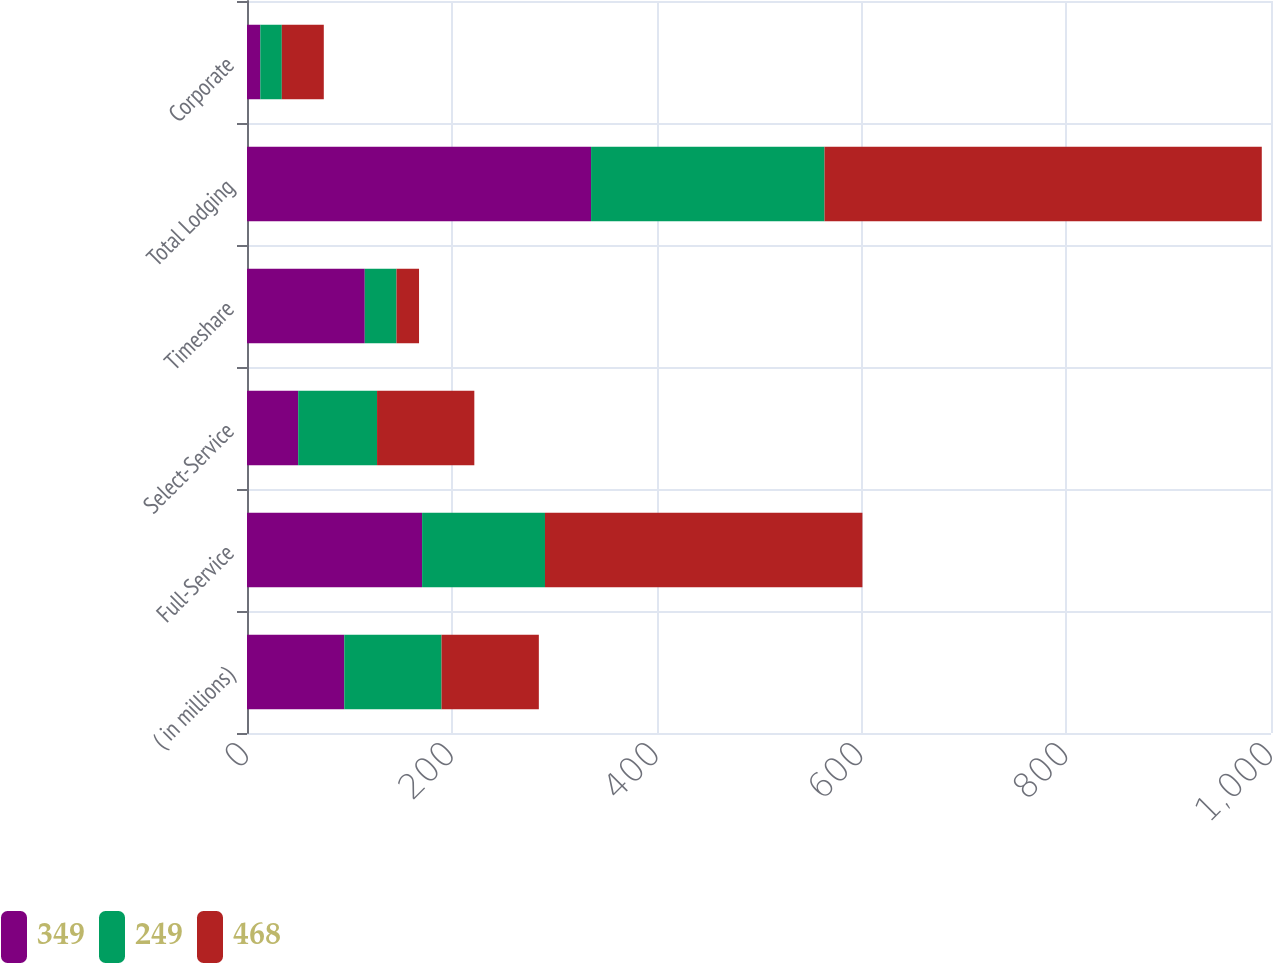Convert chart to OTSL. <chart><loc_0><loc_0><loc_500><loc_500><stacked_bar_chart><ecel><fcel>( in millions)<fcel>Full-Service<fcel>Select-Service<fcel>Timeshare<fcel>Total Lodging<fcel>Corporate<nl><fcel>349<fcel>95<fcel>171<fcel>50<fcel>115<fcel>336<fcel>13<nl><fcel>249<fcel>95<fcel>120<fcel>77<fcel>31<fcel>228<fcel>21<nl><fcel>468<fcel>95<fcel>310<fcel>95<fcel>22<fcel>427<fcel>41<nl></chart> 